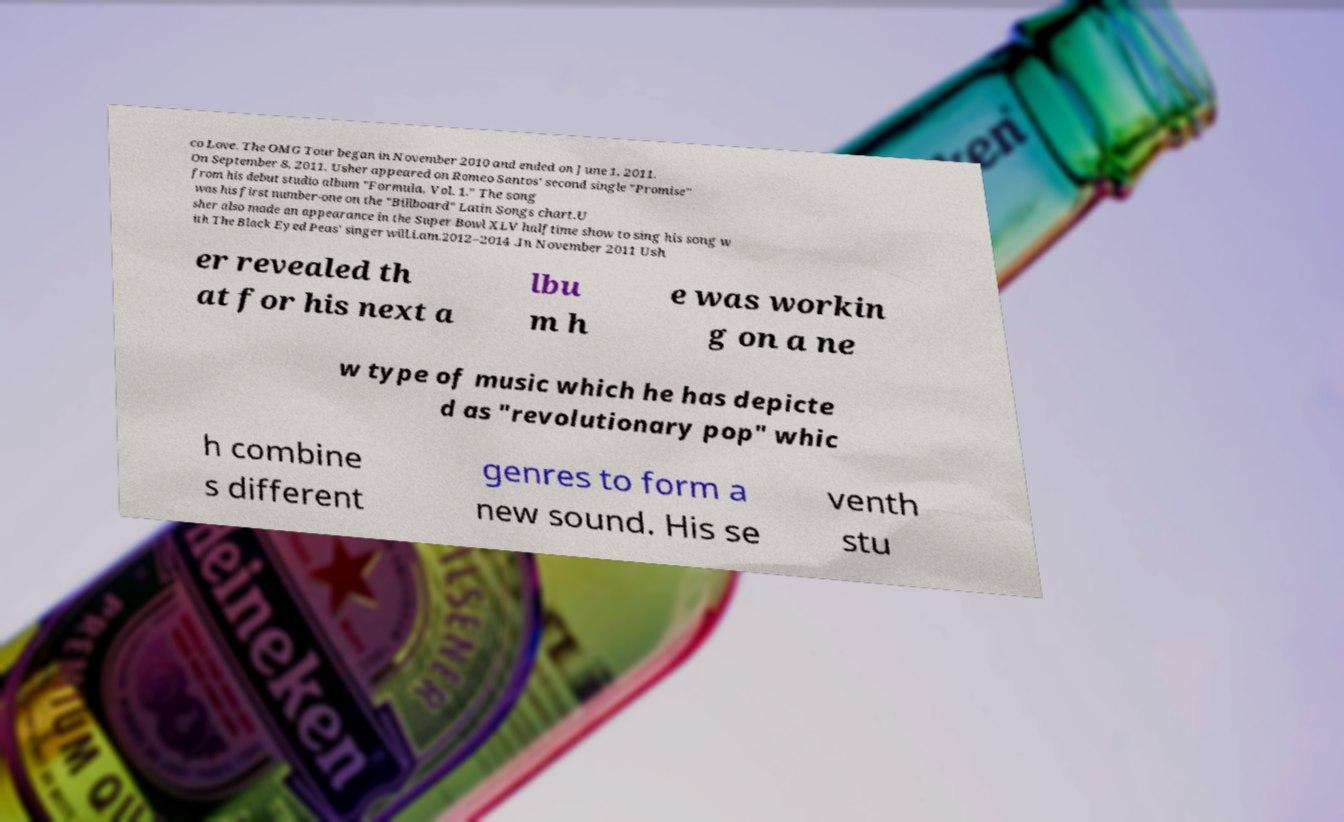For documentation purposes, I need the text within this image transcribed. Could you provide that? co Love. The OMG Tour began in November 2010 and ended on June 1, 2011. On September 8, 2011, Usher appeared on Romeo Santos' second single "Promise" from his debut studio album "Formula, Vol. 1." The song was his first number-one on the "Billboard" Latin Songs chart.U sher also made an appearance in the Super Bowl XLV halftime show to sing his song w ith The Black Eyed Peas' singer will.i.am.2012–2014 .In November 2011 Ush er revealed th at for his next a lbu m h e was workin g on a ne w type of music which he has depicte d as "revolutionary pop" whic h combine s different genres to form a new sound. His se venth stu 